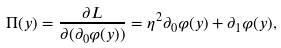<formula> <loc_0><loc_0><loc_500><loc_500>\Pi ( y ) = \frac { \partial L } { \partial ( \partial _ { 0 } \varphi ( y ) ) } = \eta ^ { 2 } \partial _ { 0 } \varphi ( y ) + \partial _ { 1 } \varphi ( y ) ,</formula> 